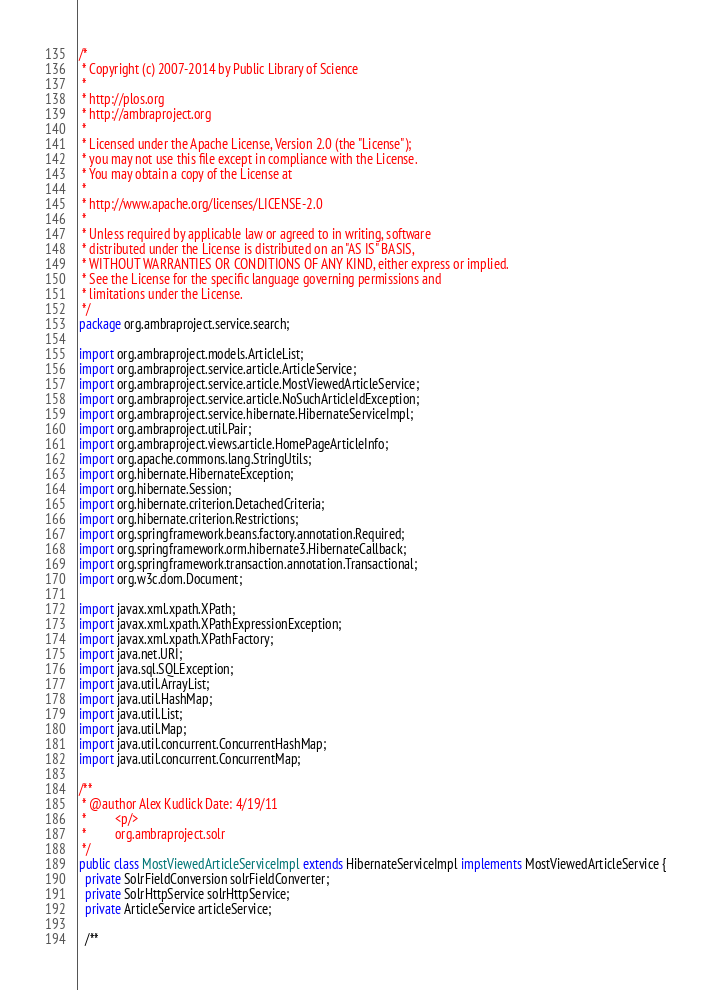Convert code to text. <code><loc_0><loc_0><loc_500><loc_500><_Java_>/*
 * Copyright (c) 2007-2014 by Public Library of Science
 *
 * http://plos.org
 * http://ambraproject.org
 *
 * Licensed under the Apache License, Version 2.0 (the "License");
 * you may not use this file except in compliance with the License.
 * You may obtain a copy of the License at
 *
 * http://www.apache.org/licenses/LICENSE-2.0
 *
 * Unless required by applicable law or agreed to in writing, software
 * distributed under the License is distributed on an "AS IS" BASIS,
 * WITHOUT WARRANTIES OR CONDITIONS OF ANY KIND, either express or implied.
 * See the License for the specific language governing permissions and
 * limitations under the License.
 */
package org.ambraproject.service.search;

import org.ambraproject.models.ArticleList;
import org.ambraproject.service.article.ArticleService;
import org.ambraproject.service.article.MostViewedArticleService;
import org.ambraproject.service.article.NoSuchArticleIdException;
import org.ambraproject.service.hibernate.HibernateServiceImpl;
import org.ambraproject.util.Pair;
import org.ambraproject.views.article.HomePageArticleInfo;
import org.apache.commons.lang.StringUtils;
import org.hibernate.HibernateException;
import org.hibernate.Session;
import org.hibernate.criterion.DetachedCriteria;
import org.hibernate.criterion.Restrictions;
import org.springframework.beans.factory.annotation.Required;
import org.springframework.orm.hibernate3.HibernateCallback;
import org.springframework.transaction.annotation.Transactional;
import org.w3c.dom.Document;

import javax.xml.xpath.XPath;
import javax.xml.xpath.XPathExpressionException;
import javax.xml.xpath.XPathFactory;
import java.net.URI;
import java.sql.SQLException;
import java.util.ArrayList;
import java.util.HashMap;
import java.util.List;
import java.util.Map;
import java.util.concurrent.ConcurrentHashMap;
import java.util.concurrent.ConcurrentMap;

/**
 * @author Alex Kudlick Date: 4/19/11
 *         <p/>
 *         org.ambraproject.solr
 */
public class MostViewedArticleServiceImpl extends HibernateServiceImpl implements MostViewedArticleService {
  private SolrFieldConversion solrFieldConverter;
  private SolrHttpService solrHttpService;
  private ArticleService articleService;

  /**</code> 